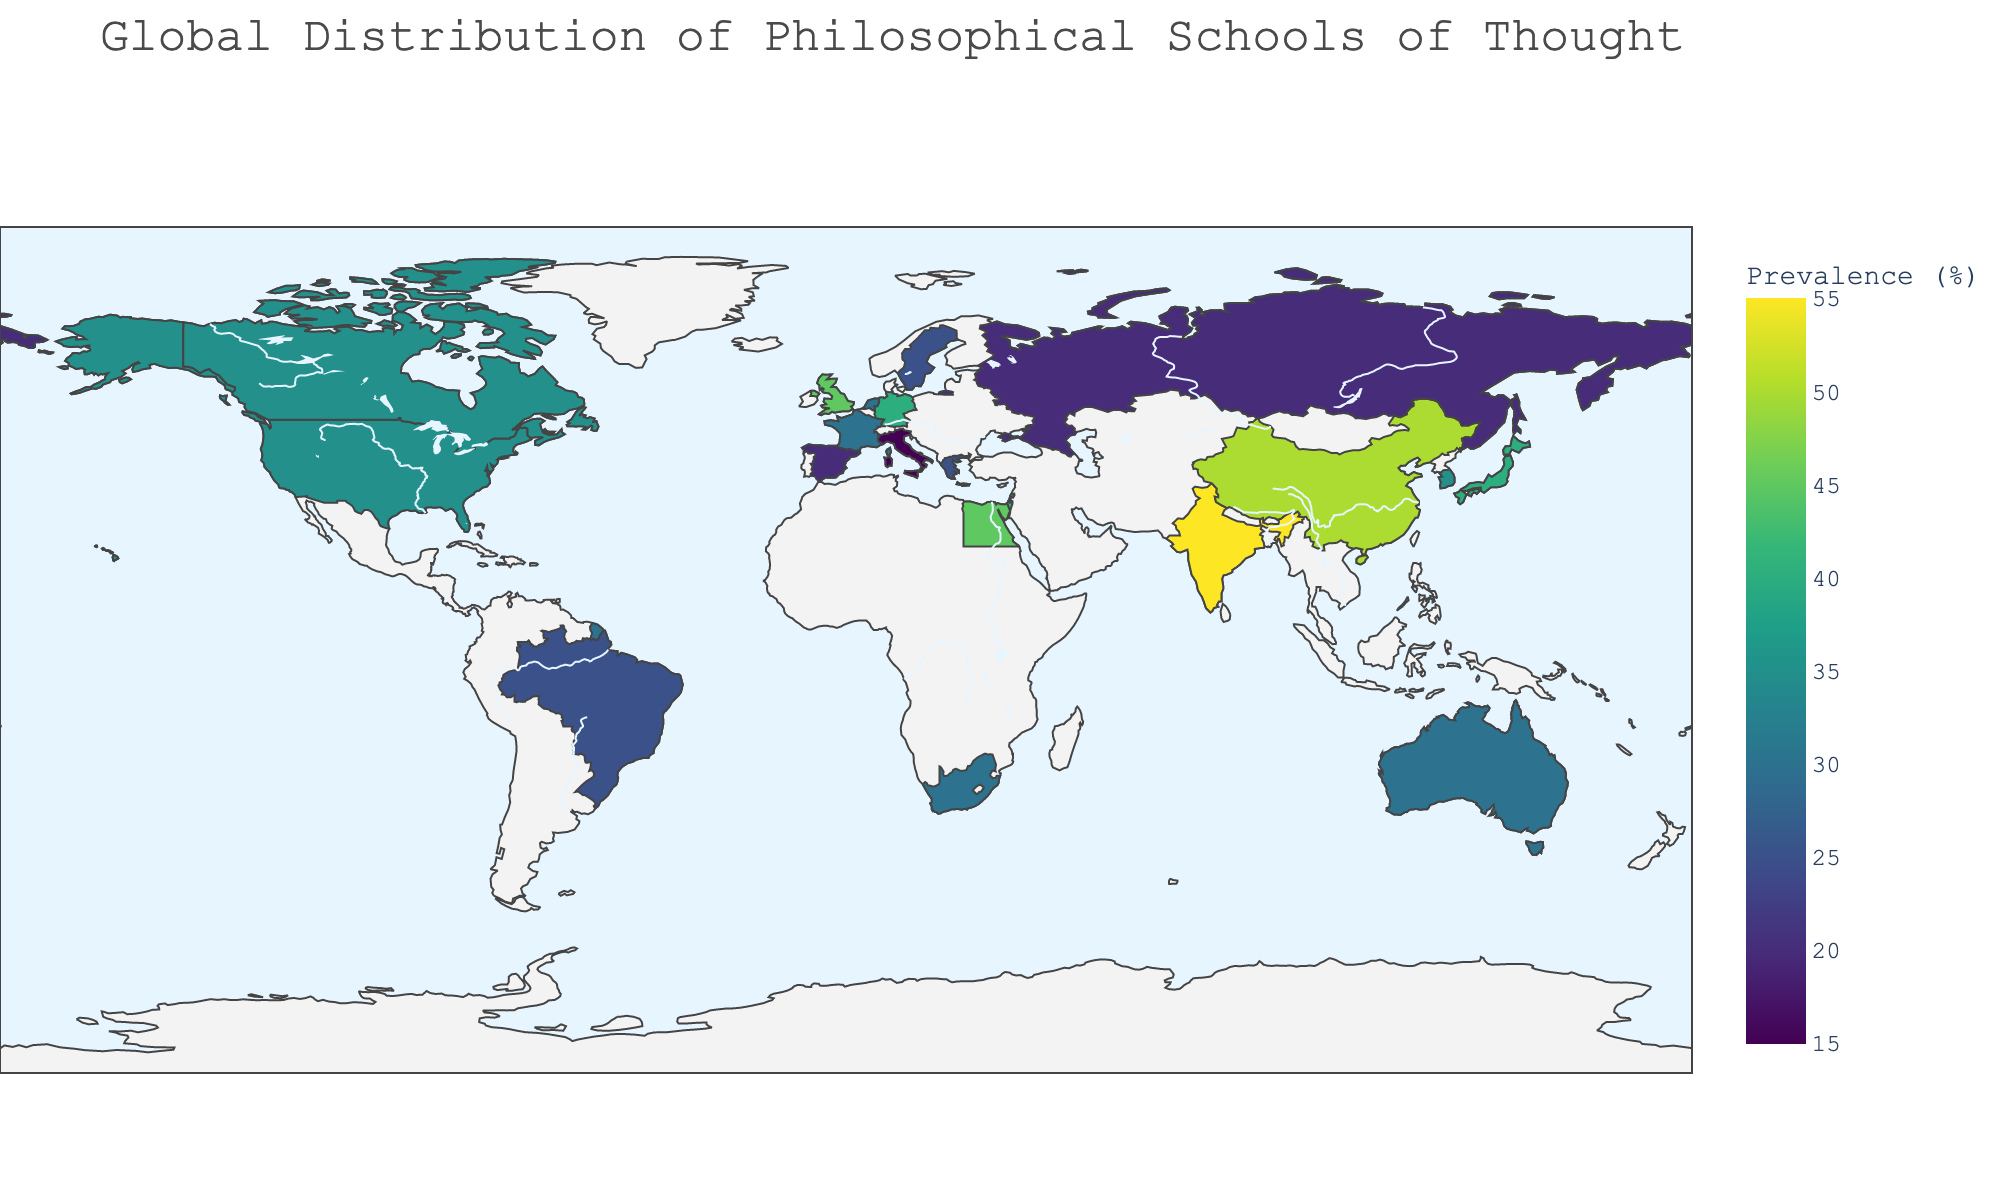What's the dominant philosophy in China? To find the dominant philosophy in China, locate China on the map, then refer to the annotation or hover information provided. It shows that Confucianism is the dominant philosophy with 50% prevalence.
Answer: Confucianism Which country has the highest prevalence of Eastern Philosophy? To determine this, find India on the map and check its annotation which indicates the percentage of prevalence for Eastern Philosophy. The map shows that India has 55% prevalence of Eastern Philosophy.
Answer: India What are the percentages of Pragmatism and Multiculturalism in their respective countries? To find this, look in the figure for the annotations or hover data for the United States and Canada. The percentage for Pragmatism in the United States is 35%, and for Multiculturalism in Canada, it is also 35%.
Answer: 35% and 35% Which countries have a dominant philosophical school with a prevalence of at least 40%? We need to check the annotations or hover data on the map for countries meeting this criteria. Germany (40% Continental Philosophy), United Kingdom (45% Analytic Philosophy), India (55% Eastern Philosophy), China (50% Confucianism), Japan (40% Zen Buddhism), Israel (40% Jewish Philosophy), and Egypt (45% Islamic Philosophy) meet this criterion.
Answer: Germany, United Kingdom, India, China, Japan, Israel, Egypt Compare the prevalence of Marxism in Russia and Roman Stoicism in Italy; which one has a higher percentage? Check the annotations or hover data for both Russia and Italy. Russia has Marxism with 20% prevalence while Italy has Roman Stoicism with 15% prevalence. Marxism has the higher percentage.
Answer: Marxism in Russia What is the least prevalent philosophy represented on the map? Survey the map's annotations to identify the lowest percentage. Roman Stoicism with 15% in Italy is the least prevalent philosophy.
Answer: Roman Stoicism How does the prevalence of Ubuntu Philosophy in South Africa compare to Environmental Philosophy in Australia? Find Australia and South Africa on the map and check the percentages. Australia has 30% prevalence for Environmental Philosophy while South Africa has 30% prevalence for Ubuntu Philosophy. Both have equal prevalence.
Answer: Equal (30%) Which country has the highest prevalence of a philosophical school of thought? Review the annotations for each country to find the highest percentage. India has the highest prevalence with 55% for Eastern Philosophy.
Answer: India What's the prevalence of Thomism and where is it most found? Locate Spain on the map and check its annotation for the prevalent school of philosophy and the corresponding percentage. The map shows that Spain has 20% prevalence for Thomism.
Answer: 20% in Spain What philosophical school is most prevalent in the United Kingdom and by what percentage? Locate the United Kingdom on the map and read its annotation or hover data. The United Kingdom shows 45% prevalence for Analytic Philosophy.
Answer: Analytic Philosophy, 45% 